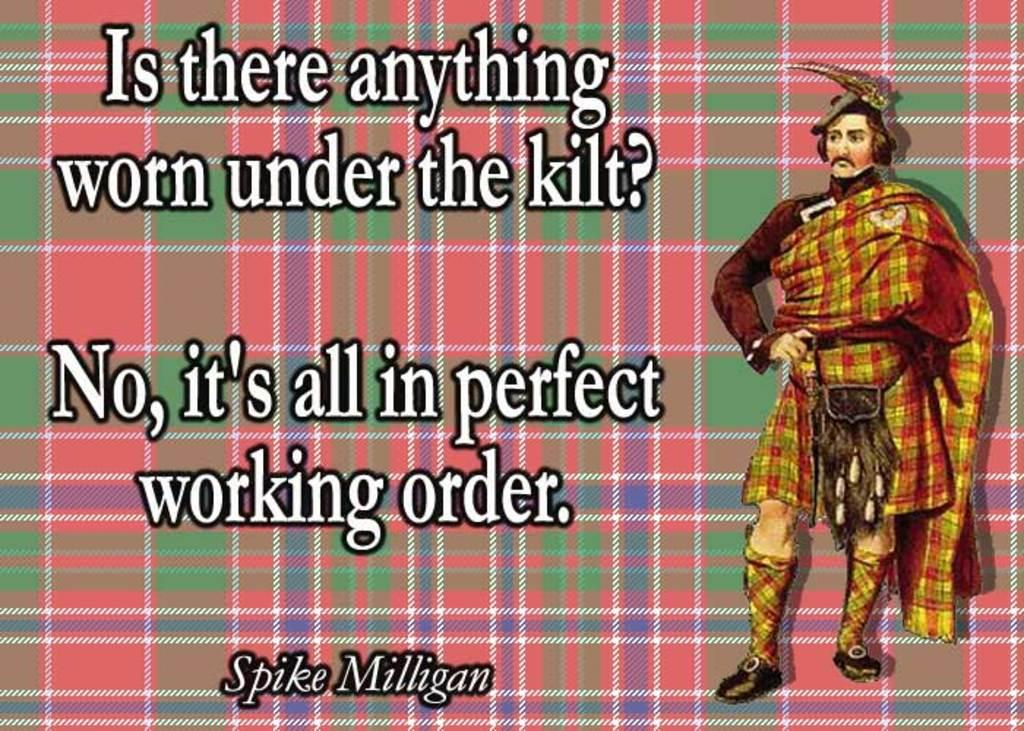What type of image is being described? The image is animated. What else can be found in the image besides the animation? There is text present in the image. Who or what is depicted in the image? There is a picture of a man in the image. How is the man dressed in the image? The man is wearing a different kind of dress. What type of stove can be seen in the image? There is no stove present in the image. What time of day is depicted in the image? The time of day is not mentioned or depicted in the image. 